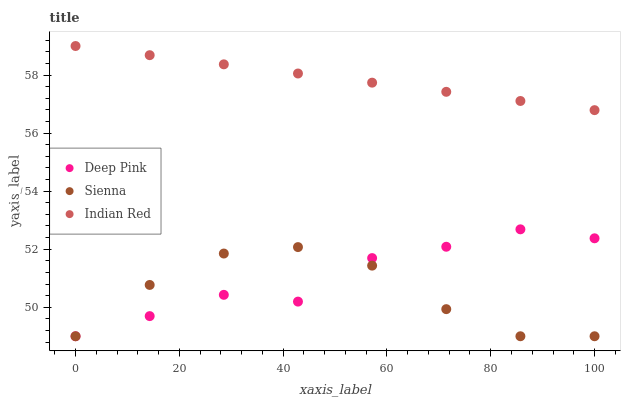Does Sienna have the minimum area under the curve?
Answer yes or no. Yes. Does Indian Red have the maximum area under the curve?
Answer yes or no. Yes. Does Deep Pink have the minimum area under the curve?
Answer yes or no. No. Does Deep Pink have the maximum area under the curve?
Answer yes or no. No. Is Indian Red the smoothest?
Answer yes or no. Yes. Is Deep Pink the roughest?
Answer yes or no. Yes. Is Deep Pink the smoothest?
Answer yes or no. No. Is Indian Red the roughest?
Answer yes or no. No. Does Sienna have the lowest value?
Answer yes or no. Yes. Does Indian Red have the lowest value?
Answer yes or no. No. Does Indian Red have the highest value?
Answer yes or no. Yes. Does Deep Pink have the highest value?
Answer yes or no. No. Is Deep Pink less than Indian Red?
Answer yes or no. Yes. Is Indian Red greater than Deep Pink?
Answer yes or no. Yes. Does Deep Pink intersect Sienna?
Answer yes or no. Yes. Is Deep Pink less than Sienna?
Answer yes or no. No. Is Deep Pink greater than Sienna?
Answer yes or no. No. Does Deep Pink intersect Indian Red?
Answer yes or no. No. 